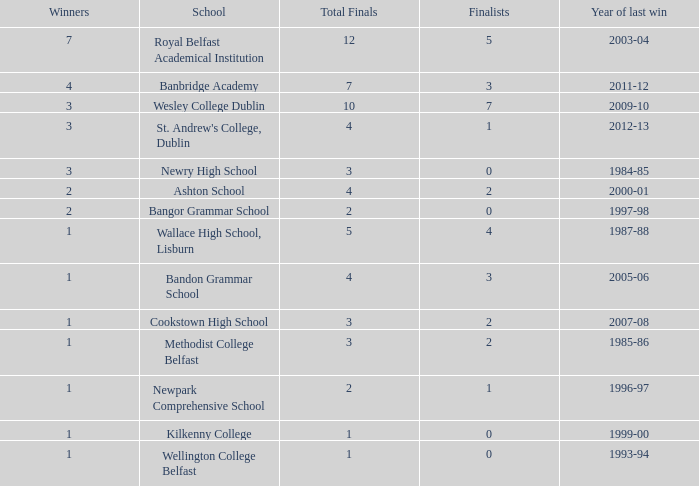What the name of  the school where the last win in 2007-08? Cookstown High School. Would you mind parsing the complete table? {'header': ['Winners', 'School', 'Total Finals', 'Finalists', 'Year of last win'], 'rows': [['7', 'Royal Belfast Academical Institution', '12', '5', '2003-04'], ['4', 'Banbridge Academy', '7', '3', '2011-12'], ['3', 'Wesley College Dublin', '10', '7', '2009-10'], ['3', "St. Andrew's College, Dublin", '4', '1', '2012-13'], ['3', 'Newry High School', '3', '0', '1984-85'], ['2', 'Ashton School', '4', '2', '2000-01'], ['2', 'Bangor Grammar School', '2', '0', '1997-98'], ['1', 'Wallace High School, Lisburn', '5', '4', '1987-88'], ['1', 'Bandon Grammar School', '4', '3', '2005-06'], ['1', 'Cookstown High School', '3', '2', '2007-08'], ['1', 'Methodist College Belfast', '3', '2', '1985-86'], ['1', 'Newpark Comprehensive School', '2', '1', '1996-97'], ['1', 'Kilkenny College', '1', '0', '1999-00'], ['1', 'Wellington College Belfast', '1', '0', '1993-94']]} 